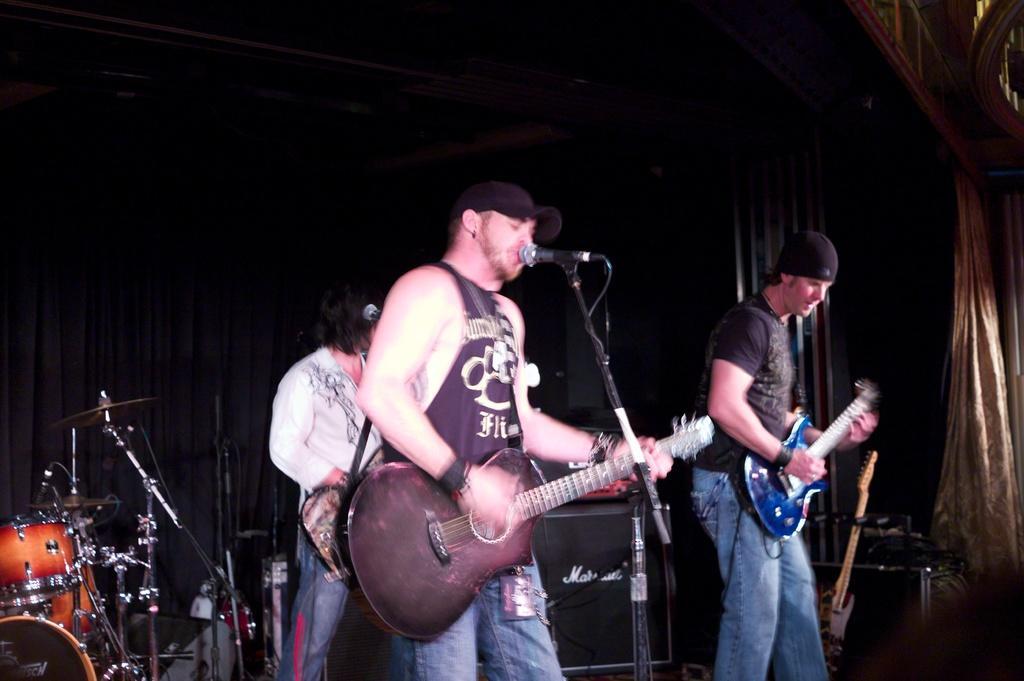Describe this image in one or two sentences. A rock band is performing in concert in which three men holding guitars. The man with a black cap is singing. There is drum set behind them. 